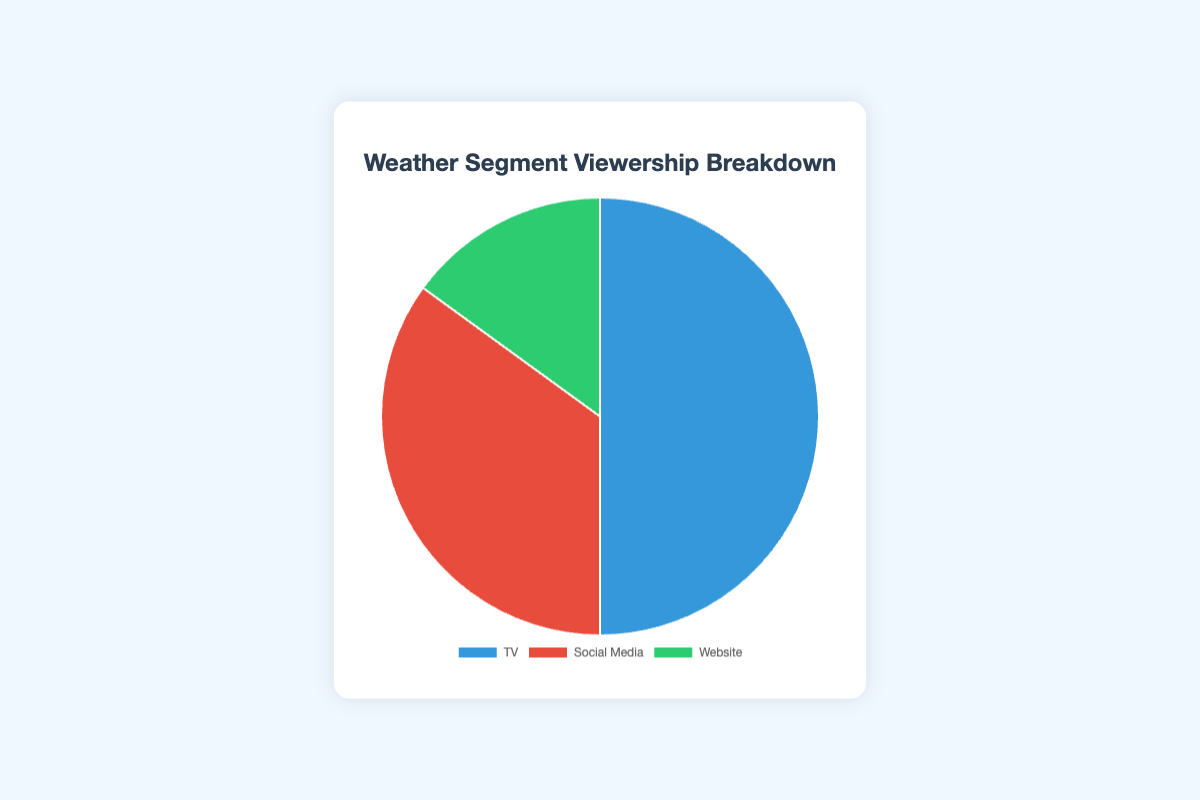What percentage of viewership is from Social Media? The Social Media segment of the pie chart shows a 35% viewership.
Answer: 35% Which platform has the highest viewership percentage? The TV segment of the pie chart shows a 50% viewership, which is higher than both Social Media (35%) and Website (15%).
Answer: TV What is the combined viewership percentage of Social Media and Website? The Social Media segment shows 35% and the Website segment shows 15%. Combined, they are 35% + 15% = 50%.
Answer: 50% How much less is the viewership percentage of the Website platform compared to the TV platform? The TV segment shows 50% and the Website shows 15%. The difference between them is 50% - 15% = 35%.
Answer: 35% Which platform has the smallest share of viewership, and what percentage is it? The Website segment has the smallest share of viewership at 15%. It is the smallest segment in the pie chart.
Answer: Website, 15% How many more percent of viewers does TV have compared to Social Media? The TV segment has 50%, and Social Media has 35%. The difference is 50% - 35% = 15%.
Answer: 15% If you combine the viewership percentages of the two platforms with the lowest viewership, will it exceed the TV viewership percentage? Social Media and Website have 35% and 15% respectively. Their combined viewership is 35% + 15% = 50%, which equals the TV viewership percentage of 50%.
Answer: No, it will equal Which segment is represented by the blue color in the pie chart? The blue color in the pie chart represents the TV segment.
Answer: TV What is the difference between the highest and the lowest viewership percentages in the chart? The highest viewership percentage is TV at 50%, and the lowest is Website at 15%. The difference is 50% - 15% = 35%.
Answer: 35% According to the chart, what percentage of the total viewership is not from Social Media? The total viewership is 100%. The Social Media viewership is 35%. The percentage not from Social Media is 100% - 35% = 65%.
Answer: 65% 